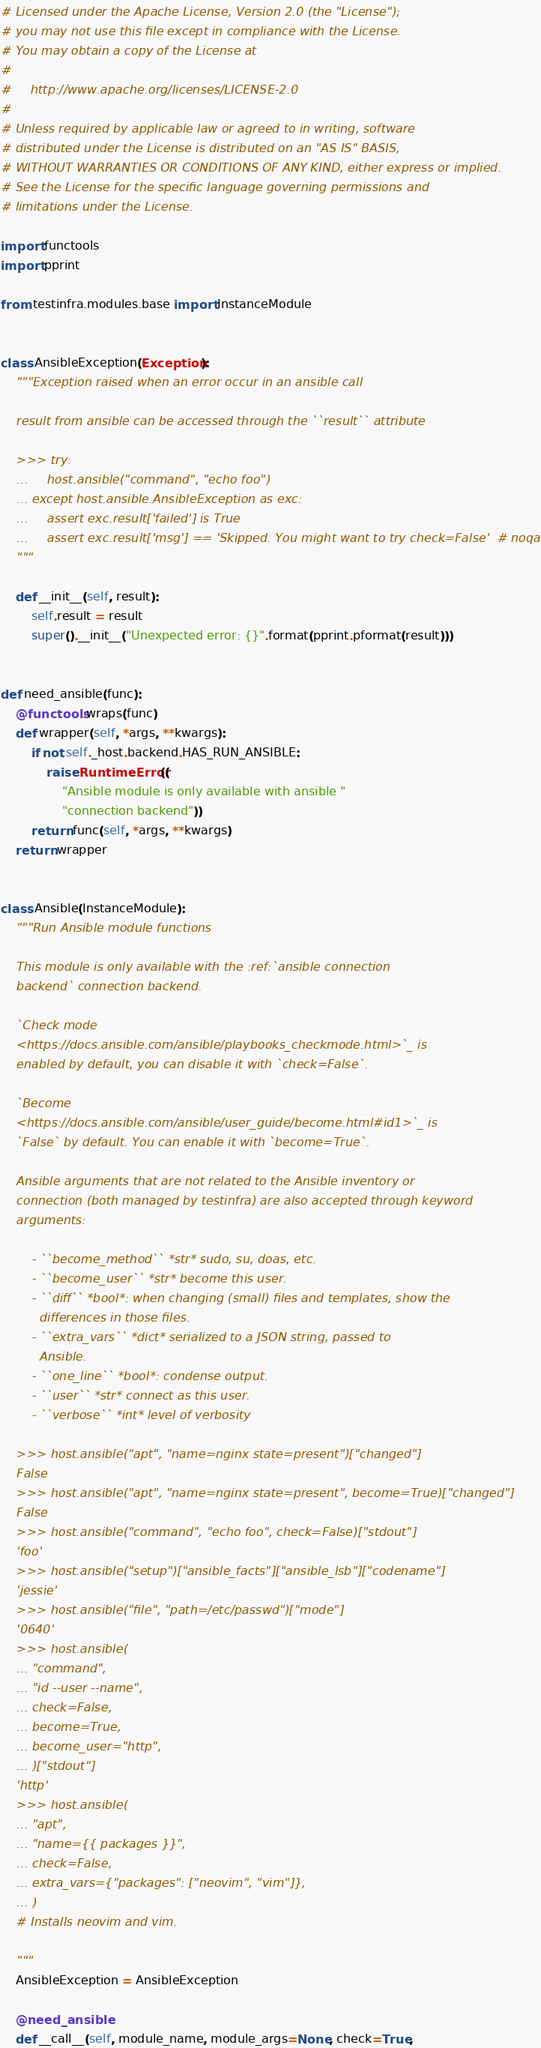Convert code to text. <code><loc_0><loc_0><loc_500><loc_500><_Python_># Licensed under the Apache License, Version 2.0 (the "License");
# you may not use this file except in compliance with the License.
# You may obtain a copy of the License at
#
#     http://www.apache.org/licenses/LICENSE-2.0
#
# Unless required by applicable law or agreed to in writing, software
# distributed under the License is distributed on an "AS IS" BASIS,
# WITHOUT WARRANTIES OR CONDITIONS OF ANY KIND, either express or implied.
# See the License for the specific language governing permissions and
# limitations under the License.

import functools
import pprint

from testinfra.modules.base import InstanceModule


class AnsibleException(Exception):
    """Exception raised when an error occur in an ansible call

    result from ansible can be accessed through the ``result`` attribute

    >>> try:
    ...     host.ansible("command", "echo foo")
    ... except host.ansible.AnsibleException as exc:
    ...     assert exc.result['failed'] is True
    ...     assert exc.result['msg'] == 'Skipped. You might want to try check=False'  # noqa
    """

    def __init__(self, result):
        self.result = result
        super().__init__("Unexpected error: {}".format(pprint.pformat(result)))


def need_ansible(func):
    @functools.wraps(func)
    def wrapper(self, *args, **kwargs):
        if not self._host.backend.HAS_RUN_ANSIBLE:
            raise RuntimeError((
                "Ansible module is only available with ansible "
                "connection backend"))
        return func(self, *args, **kwargs)
    return wrapper


class Ansible(InstanceModule):
    """Run Ansible module functions

    This module is only available with the :ref:`ansible connection
    backend` connection backend.

    `Check mode
    <https://docs.ansible.com/ansible/playbooks_checkmode.html>`_ is
    enabled by default, you can disable it with `check=False`.

    `Become
    <https://docs.ansible.com/ansible/user_guide/become.html#id1>`_ is
    `False` by default. You can enable it with `become=True`.

    Ansible arguments that are not related to the Ansible inventory or
    connection (both managed by testinfra) are also accepted through keyword
    arguments:

        - ``become_method`` *str* sudo, su, doas, etc.
        - ``become_user`` *str* become this user.
        - ``diff`` *bool*: when changing (small) files and templates, show the
          differences in those files.
        - ``extra_vars`` *dict* serialized to a JSON string, passed to
          Ansible.
        - ``one_line`` *bool*: condense output.
        - ``user`` *str* connect as this user.
        - ``verbose`` *int* level of verbosity

    >>> host.ansible("apt", "name=nginx state=present")["changed"]
    False
    >>> host.ansible("apt", "name=nginx state=present", become=True)["changed"]
    False
    >>> host.ansible("command", "echo foo", check=False)["stdout"]
    'foo'
    >>> host.ansible("setup")["ansible_facts"]["ansible_lsb"]["codename"]
    'jessie'
    >>> host.ansible("file", "path=/etc/passwd")["mode"]
    '0640'
    >>> host.ansible(
    ... "command",
    ... "id --user --name",
    ... check=False,
    ... become=True,
    ... become_user="http",
    ... )["stdout"]
    'http'
    >>> host.ansible(
    ... "apt",
    ... "name={{ packages }}",
    ... check=False,
    ... extra_vars={"packages": ["neovim", "vim"]},
    ... )
    # Installs neovim and vim.

    """
    AnsibleException = AnsibleException

    @need_ansible
    def __call__(self, module_name, module_args=None, check=True,</code> 